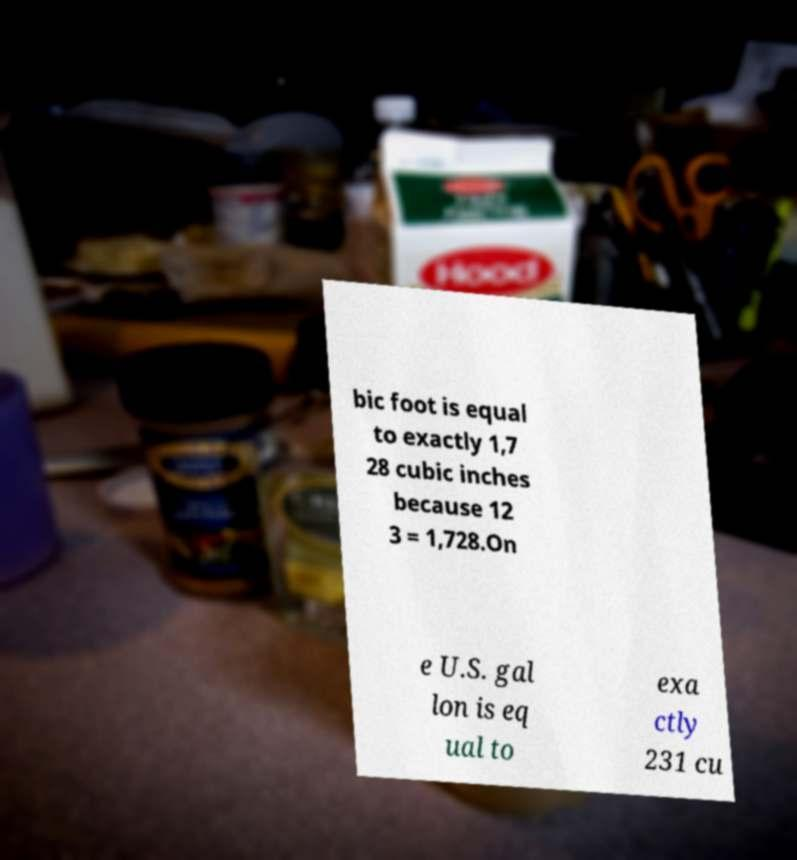What messages or text are displayed in this image? I need them in a readable, typed format. bic foot is equal to exactly 1,7 28 cubic inches because 12 3 = 1,728.On e U.S. gal lon is eq ual to exa ctly 231 cu 